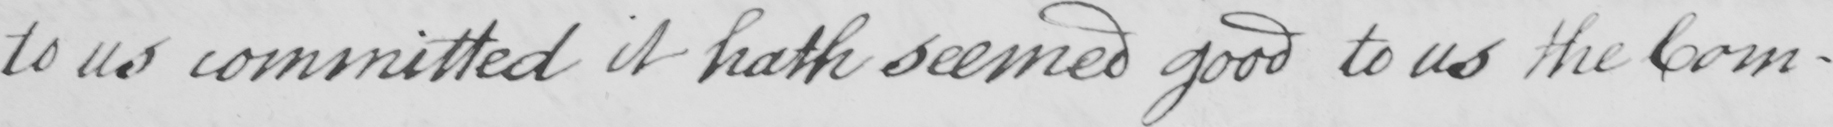Please provide the text content of this handwritten line. to us committed it hath seemed good to us the Com- 